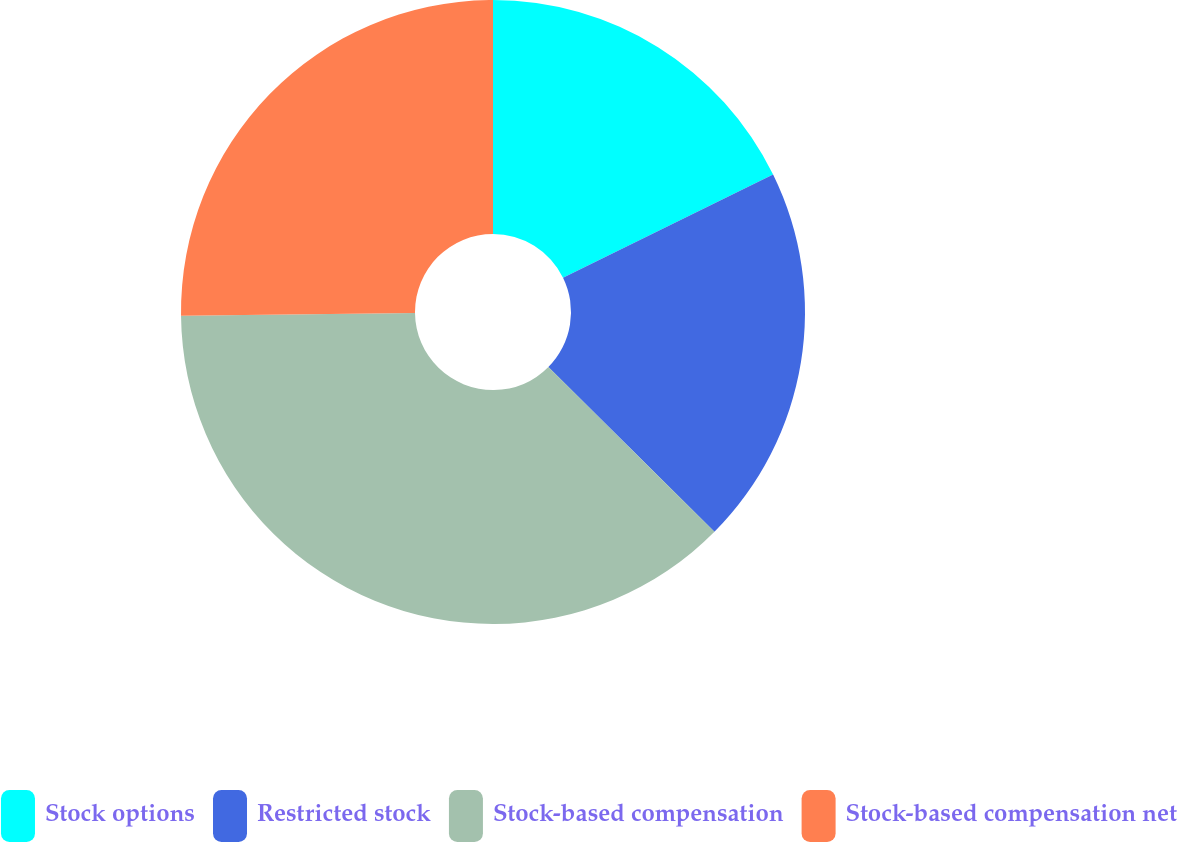Convert chart to OTSL. <chart><loc_0><loc_0><loc_500><loc_500><pie_chart><fcel>Stock options<fcel>Restricted stock<fcel>Stock-based compensation<fcel>Stock-based compensation net<nl><fcel>17.74%<fcel>19.7%<fcel>37.37%<fcel>25.19%<nl></chart> 